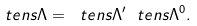<formula> <loc_0><loc_0><loc_500><loc_500>\ t e n s { \Lambda } = \ t e n s { \Lambda } ^ { \prime } \ t e n s { \Lambda } ^ { 0 } .</formula> 